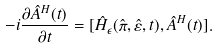<formula> <loc_0><loc_0><loc_500><loc_500>- i \frac { \partial \hat { A } ^ { H } ( t ) } { \partial t } = [ \hat { H } _ { \epsilon } ( \hat { \pi } , \hat { \varepsilon } , t ) , \hat { A } ^ { H } ( t ) ] .</formula> 